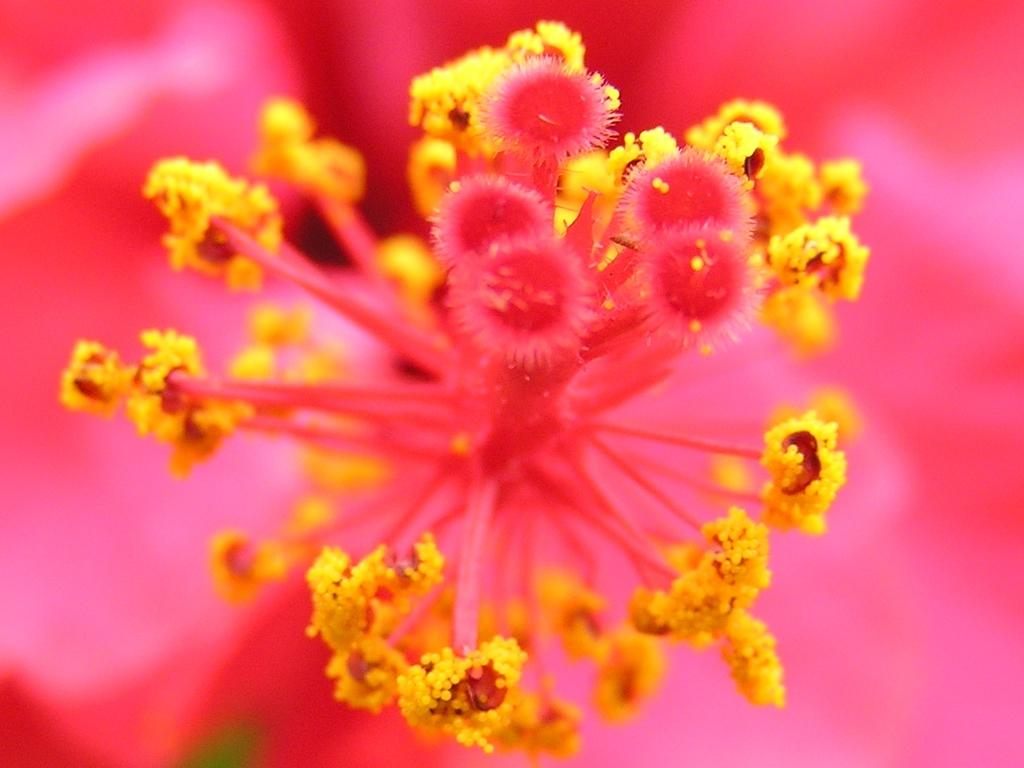What is the main subject in the foreground of the image? There is a flower in the foreground of the image. What color is the background of the image? The background of the image is pink. How many parents are visible in the image? There are no parents present in the image; it features a flower in the foreground and a pink background. What type of nail is being used to hold the flower in the image? There is no nail present in the image; it features a flower in the foreground and a pink background. 